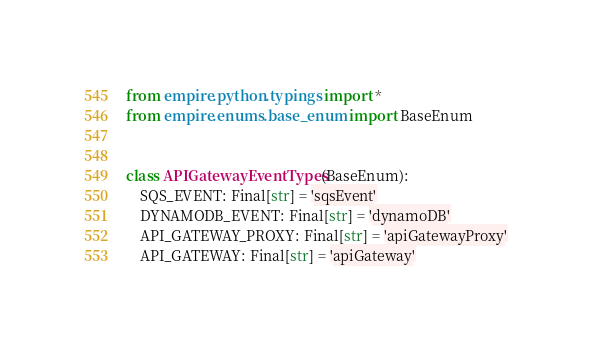<code> <loc_0><loc_0><loc_500><loc_500><_Python_>from empire.python.typings import *
from empire.enums.base_enum import BaseEnum


class APIGatewayEventTypes(BaseEnum):
    SQS_EVENT: Final[str] = 'sqsEvent'
    DYNAMODB_EVENT: Final[str] = 'dynamoDB'
    API_GATEWAY_PROXY: Final[str] = 'apiGatewayProxy'
    API_GATEWAY: Final[str] = 'apiGateway'
</code> 